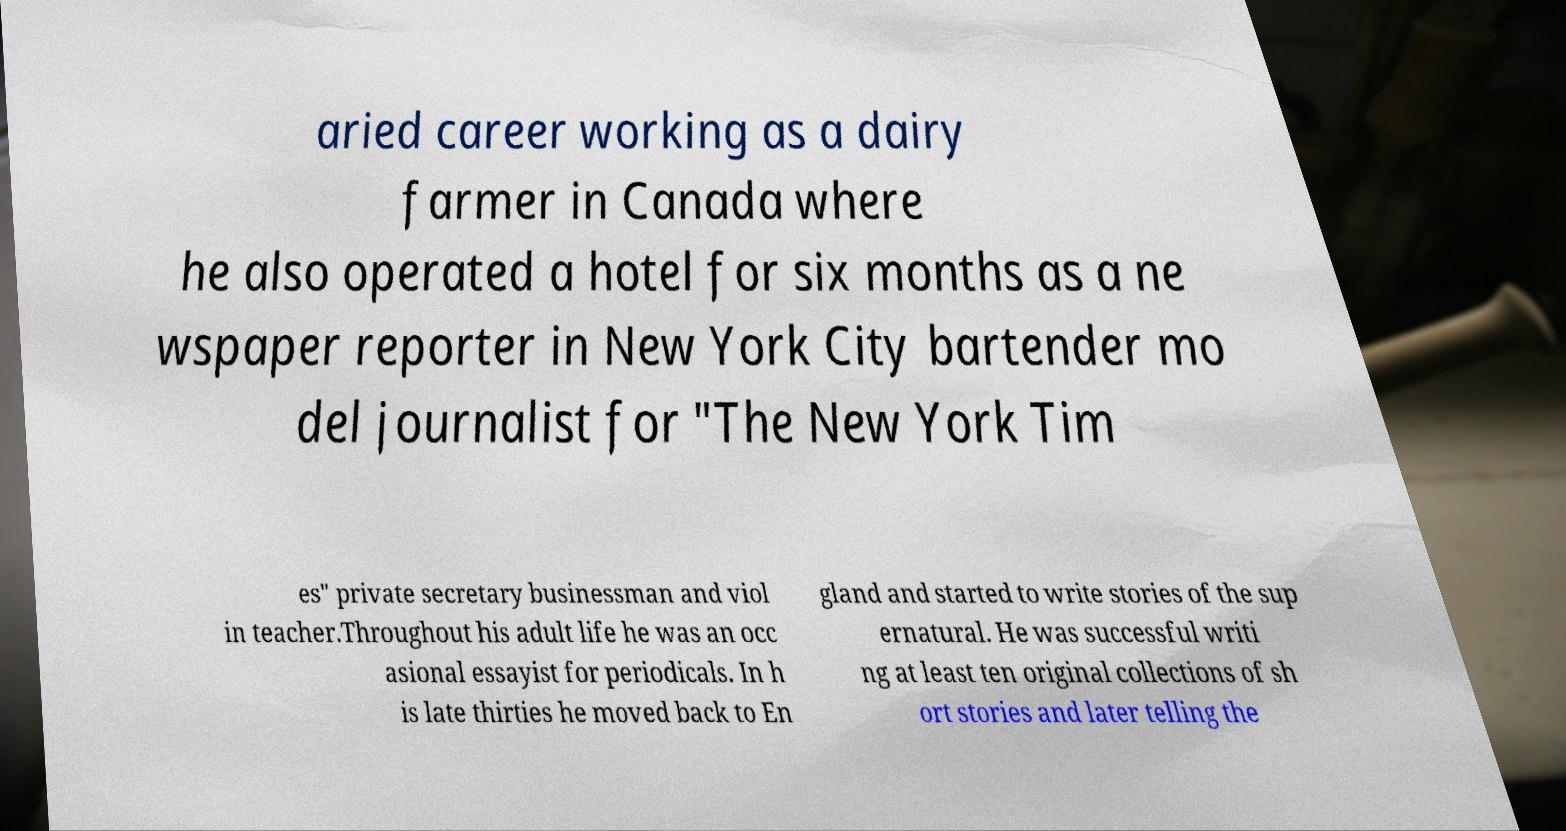Could you extract and type out the text from this image? aried career working as a dairy farmer in Canada where he also operated a hotel for six months as a ne wspaper reporter in New York City bartender mo del journalist for "The New York Tim es" private secretary businessman and viol in teacher.Throughout his adult life he was an occ asional essayist for periodicals. In h is late thirties he moved back to En gland and started to write stories of the sup ernatural. He was successful writi ng at least ten original collections of sh ort stories and later telling the 